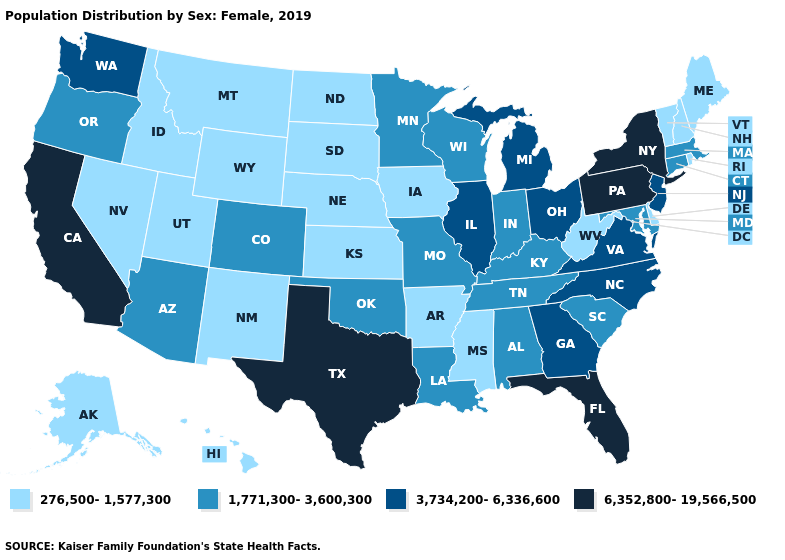Does the map have missing data?
Short answer required. No. What is the highest value in the Northeast ?
Answer briefly. 6,352,800-19,566,500. Which states have the highest value in the USA?
Write a very short answer. California, Florida, New York, Pennsylvania, Texas. Name the states that have a value in the range 3,734,200-6,336,600?
Concise answer only. Georgia, Illinois, Michigan, New Jersey, North Carolina, Ohio, Virginia, Washington. Which states have the lowest value in the South?
Short answer required. Arkansas, Delaware, Mississippi, West Virginia. Does Kentucky have the highest value in the South?
Be succinct. No. Name the states that have a value in the range 3,734,200-6,336,600?
Quick response, please. Georgia, Illinois, Michigan, New Jersey, North Carolina, Ohio, Virginia, Washington. Name the states that have a value in the range 276,500-1,577,300?
Give a very brief answer. Alaska, Arkansas, Delaware, Hawaii, Idaho, Iowa, Kansas, Maine, Mississippi, Montana, Nebraska, Nevada, New Hampshire, New Mexico, North Dakota, Rhode Island, South Dakota, Utah, Vermont, West Virginia, Wyoming. Among the states that border New York , does Pennsylvania have the highest value?
Concise answer only. Yes. What is the lowest value in states that border South Dakota?
Quick response, please. 276,500-1,577,300. What is the lowest value in the USA?
Quick response, please. 276,500-1,577,300. Name the states that have a value in the range 6,352,800-19,566,500?
Answer briefly. California, Florida, New York, Pennsylvania, Texas. What is the lowest value in the USA?
Write a very short answer. 276,500-1,577,300. What is the value of South Dakota?
Give a very brief answer. 276,500-1,577,300. Name the states that have a value in the range 1,771,300-3,600,300?
Keep it brief. Alabama, Arizona, Colorado, Connecticut, Indiana, Kentucky, Louisiana, Maryland, Massachusetts, Minnesota, Missouri, Oklahoma, Oregon, South Carolina, Tennessee, Wisconsin. 